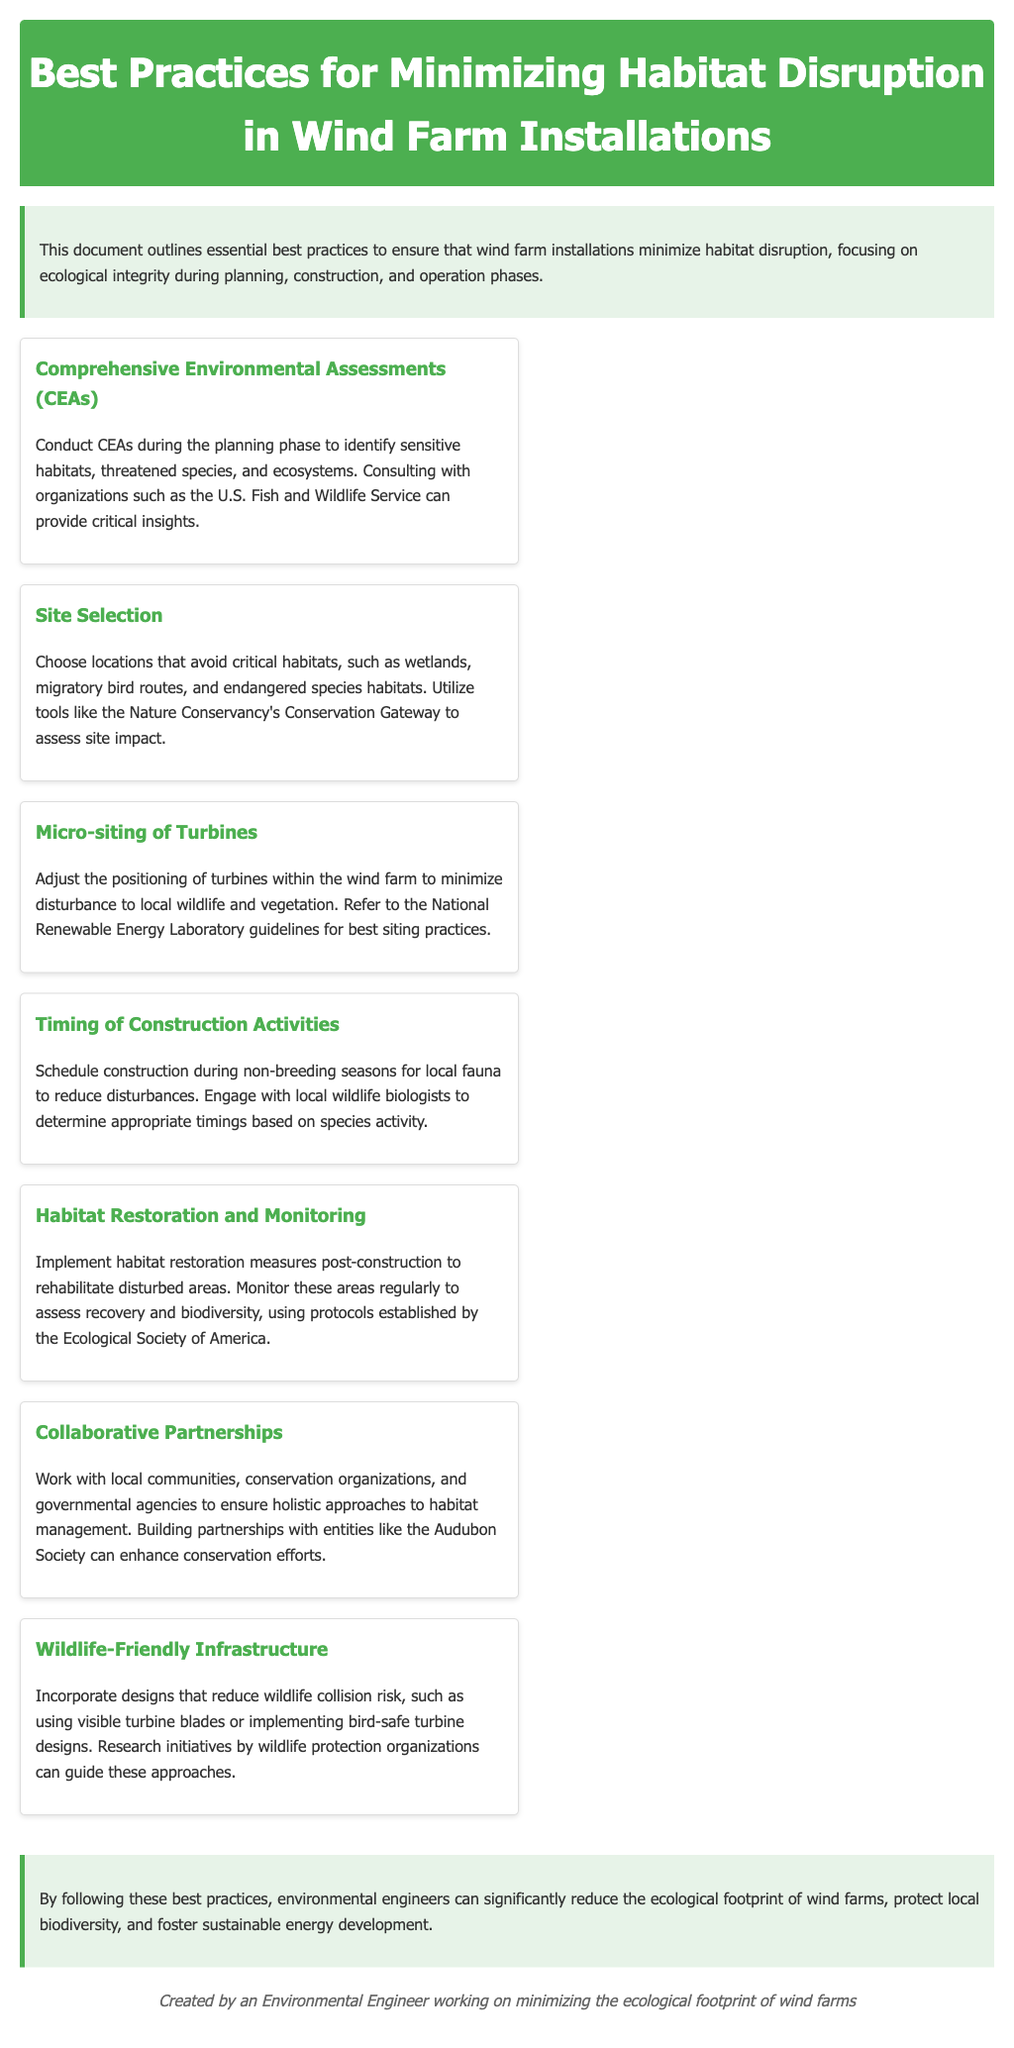what is the title of the document? The title is prominently displayed at the top of the document in the header section.
Answer: Best Practices for Minimizing Habitat Disruption in Wind Farm Installations what is a key organization mentioned for conducting CEAs? The document specifies the U.S. Fish and Wildlife Service as a key organization for insights.
Answer: U.S. Fish and Wildlife Service what should be avoided during site selection? The document emphasizes critical habitats to be avoided during site selection.
Answer: Critical habitats when should construction activities be scheduled? The document suggests scheduling during non-breeding seasons for local fauna.
Answer: Non-breeding seasons what is the purpose of habitat restoration and monitoring? The purpose is to rehabilitate disturbed areas and assess recovery and biodiversity.
Answer: Rehabilitate disturbed areas which society provides protocols for monitoring post-construction? The document references protocols established by the Ecological Society of America.
Answer: Ecological Society of America how does the document suggest reducing wildlife collision risk? The document recommends designs like using visible turbine blades or implementing bird-safe turbine designs.
Answer: Visible turbine blades who should be engaged for appropriate construction timing? The document mentions engaging local wildlife biologists for determining appropriate timings.
Answer: Local wildlife biologists 